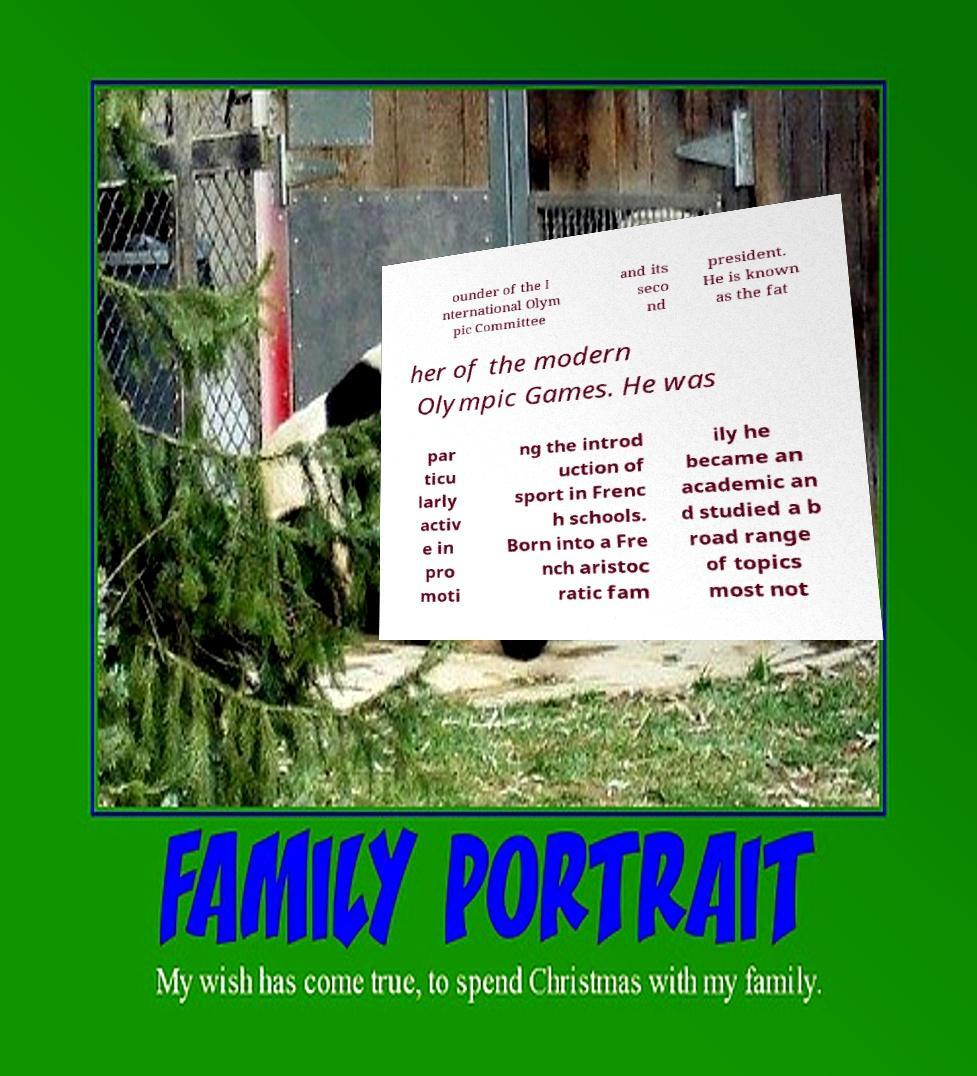Please identify and transcribe the text found in this image. ounder of the I nternational Olym pic Committee and its seco nd president. He is known as the fat her of the modern Olympic Games. He was par ticu larly activ e in pro moti ng the introd uction of sport in Frenc h schools. Born into a Fre nch aristoc ratic fam ily he became an academic an d studied a b road range of topics most not 